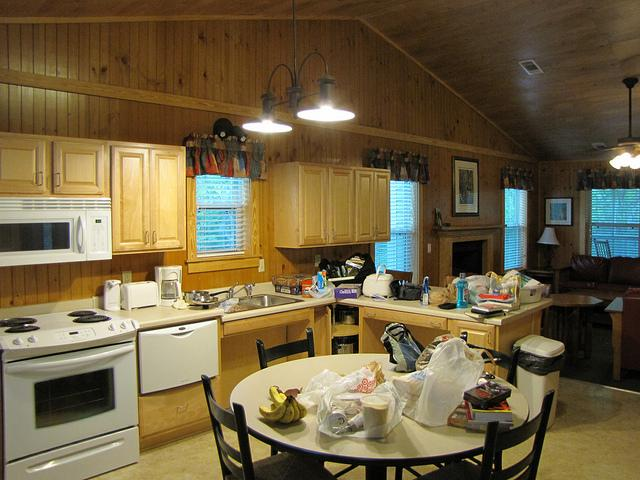What did the occupants of this home likely just get done doing? Please explain your reasoning. shop. There are grocery bags on the table. they likely just went to the grocery store. 